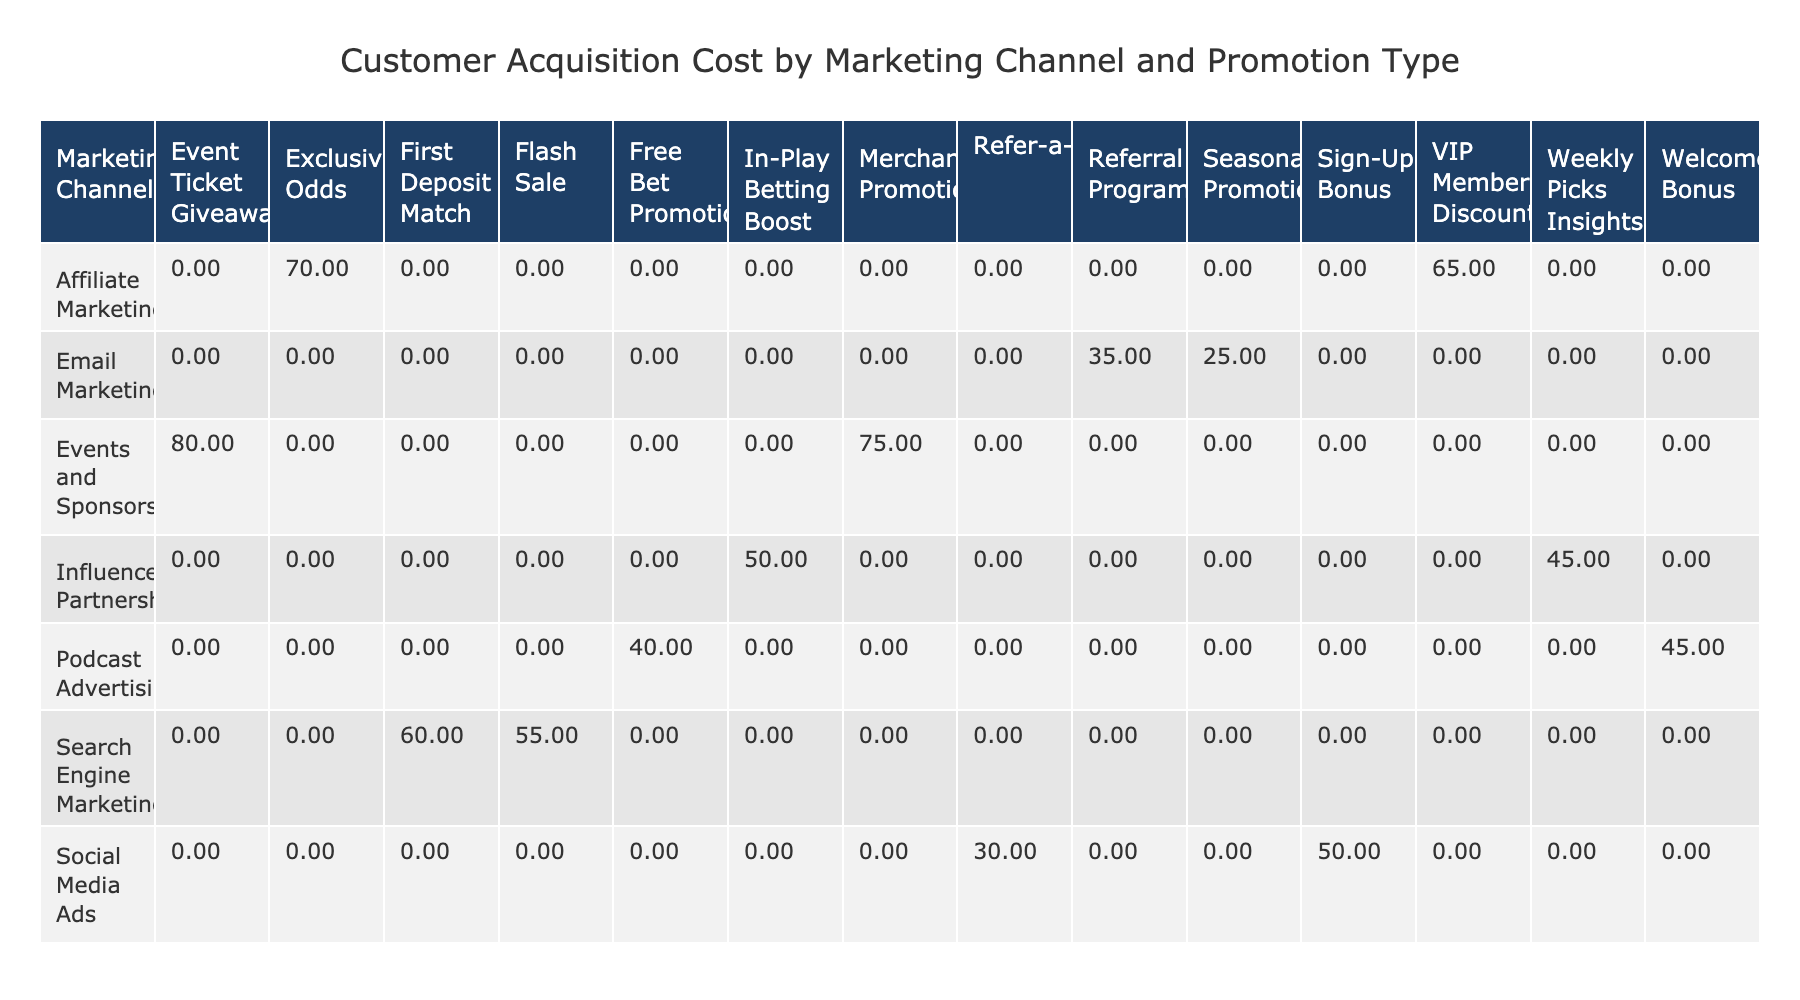What is the Customer Acquisition Cost for Podcast Advertising with a Welcome Bonus? The table shows that the Customer Acquisition Cost for Podcast Advertising when offering a Welcome Bonus is listed as 45.00.
Answer: 45.00 What is the Promotion Type with the highest Customer Acquisition Cost in Email Marketing? In the Email Marketing row, there are two promotion types: Seasonal Promotion (25.00) and Referral Program (35.00). The higher value is for the Referral Program at 35.00.
Answer: 35.00 Which marketing channel has the lowest overall Customer Acquisition Cost? To determine this, we look at the Customer Acquisition Costs for all marketing channels. Adding up the costs: Podcast Advertising (45.00 + 40.00 = 85.00), Social Media Ads (30.00 + 50.00 = 80.00), Email Marketing (25.00 + 35.00 = 60.00), Search Engine Marketing (60.00 + 55.00 = 115.00), Affiliate Marketing (70.00 + 65.00 = 135.00), Events and Sponsorship (80.00 + 75.00 = 155.00), Influencer Partnerships (50.00 + 45.00 = 95.00). The lowest total is for Email Marketing with 60.00.
Answer: Email Marketing Is the Customer Acquisition Cost for the First Deposit Match higher than that for the Free Bet Promotion? The Customer Acquisition Cost for the First Deposit Match (60.00) and the Free Bet Promotion (40.00). Since 60.00 is greater than 40.00, the statement is true.
Answer: Yes What is the average Customer Acquisition Cost for Social Media Ads? Summing the Customer Acquisition Costs for Social Media Ads, we find: 30.00 (Refer-a-Friend) + 50.00 (Sign-Up Bonus) = 80.00. Since there are two values, we divide by 2: 80.00 / 2 = 40.00.
Answer: 40.00 Which has a higher Customer Acquisition Cost: Exclusive Odds under Affiliate Marketing or Event Ticket Giveaway under Events and Sponsorship? The Customer Acquisition Cost for Exclusive Odds (70.00) is compared to Event Ticket Giveaway (80.00). Since 80.00 is higher than 70.00, Event Ticket Giveaway has the higher cost.
Answer: Event Ticket Giveaway Is the Customer Acquisition Cost for Influencer Partnerships consistently lower than 50.00? Looking at the costs for Influencer Partnerships, one is 50.00 (In-Play Betting Boost) and the other is 45.00 (Weekly Picks Insights). Since at least one is equal to or above 50.00, the statement is false.
Answer: No What is the difference in Customer Acquisition Cost between the Merchandise Promotion and the Free Bet Promotion? The Merchandise Promotion costs 75.00, while the Free Bet Promotion costs 40.00. The difference can be calculated as: 75.00 - 40.00 = 35.00.
Answer: 35.00 